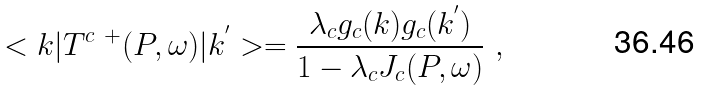Convert formula to latex. <formula><loc_0><loc_0><loc_500><loc_500>< k | T ^ { c \ + } ( P , \omega ) | k ^ { ^ { \prime } } > = \frac { \lambda _ { c } g _ { c } ( k ) g _ { c } ( k ^ { ^ { \prime } } ) } { 1 - \lambda _ { c } J _ { c } ( P , \omega ) } \ ,</formula> 